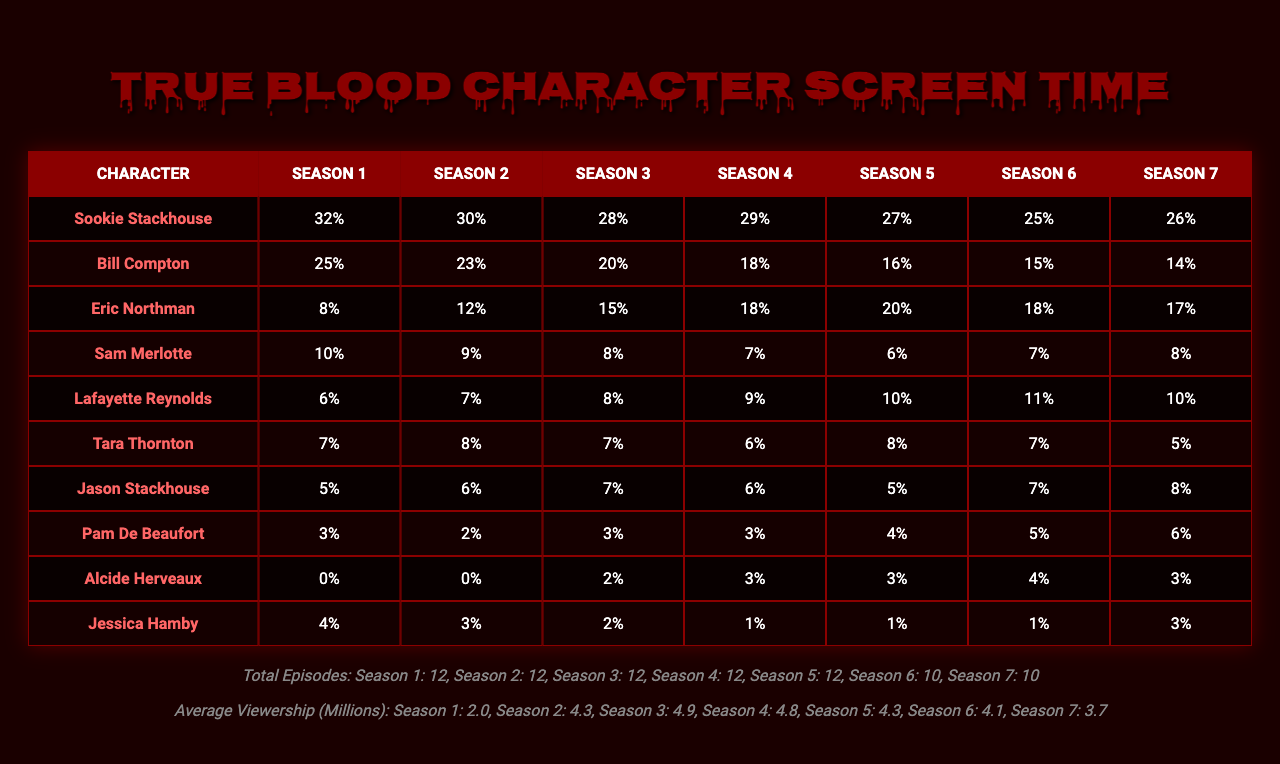What character had the highest screen time in Season 1? In Season 1, Sookie Stackhouse had the highest screen time at 32%. I refer to the corresponding row for Sookie and observe the percentage column for Season 1.
Answer: Sookie Stackhouse What is the average screen time for Eric Northman across all seasons? The screen time percentages for Eric Northman are [8, 12, 15, 18, 20, 18, 17]. Adding these gives 108%, and dividing by the number of seasons (7) gives an average of 15.43%.
Answer: 15.43% Which character had a decrease in screen time from Season 5 to Season 6? Comparing the screen time from Season 5 to Season 6, we see Bill Compton decreased from 16% to 15%. Thus, he had a decrease in screen time.
Answer: Yes In which season did Jessica Hamby have her lowest screen time? Looking at the percentages for Jessica Hamby, the lowest screen time is 1% in Season 4. This is noted by identifying the minimum value in her row.
Answer: Season 4 What is the total screen time percentage for Lafayette Reynolds over all seasons? Summing the screen time percentages for Lafayette Reynolds: 6 + 7 + 8 + 9 + 10 + 11 + 10 = 61%. This gives the total screen time for this character across all seasons.
Answer: 61% Was there a season where the average viewership exceeded 4.5 million? Yes, looking at the average viewership across the seasons, Season 3 (4.9 million) and Season 4 (4.8 million) had average viewership exceeding 4.5 million.
Answer: Yes How does the screen time of Alcide Herveaux compare between Season 3 and Season 5? Alcide Herveaux had 2% of screen time in Season 3 and 3% in Season 5. Thus, his screen time increased from Season 3 to Season 5 by 1%.
Answer: Increased by 1% What was the percentage difference in average viewership between Season 2 and Season 6? The viewership for Season 2 is 4.3 million and for Season 6 is 4.1 million. The difference is 4.3 - 4.1 = 0.2 million.
Answer: 0.2 million Which character had consistent screen time across all seasons? Sam Merlotte's screen time percentages fluctuated, but consistently remained between 6-10% without major spikes or drops. Thus, he showed consistent screen time across seasons.
Answer: No Which seasons show a decline in viewership from the previous season? Looking at the viewership data, Seasons 5 to 6 (4.3 to 4.1) and Season 4 to 5 (4.8 to 4.3) show declines when compared to their previous seasons.
Answer: Seasons 5 and 4 What is the total percentage of screen time for Sookie Stackhouse across all seasons compared to Eric Northman? For Sookie, the total is 32 + 30 + 28 + 29 + 27 + 25 + 26 = 227%. For Eric, it is 108%. Comparatively, Sookie's screen time is much higher than Eric's.
Answer: Sookie 227%, Eric 108% 